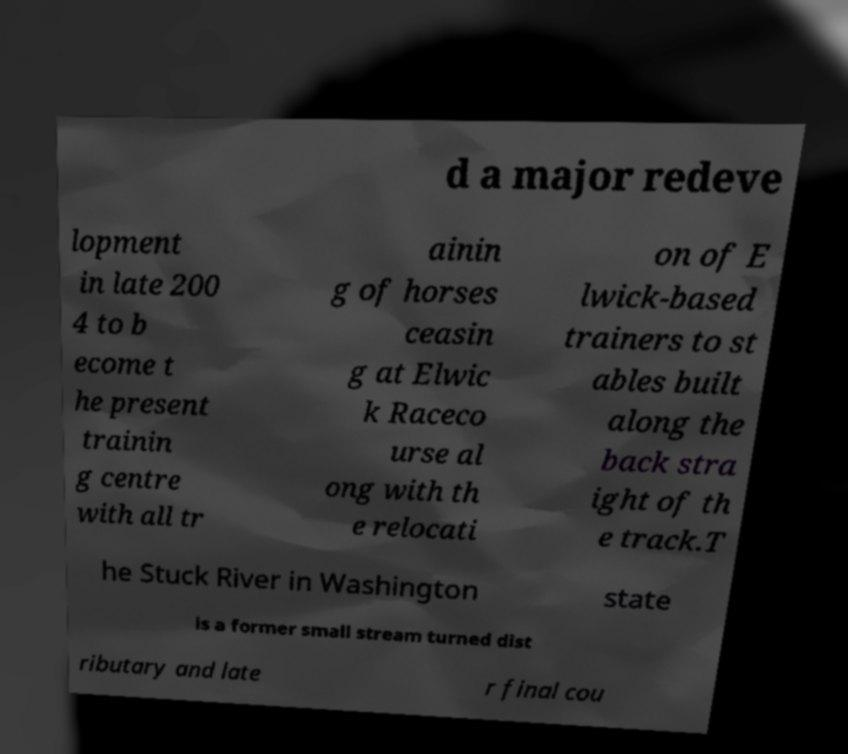Can you accurately transcribe the text from the provided image for me? d a major redeve lopment in late 200 4 to b ecome t he present trainin g centre with all tr ainin g of horses ceasin g at Elwic k Raceco urse al ong with th e relocati on of E lwick-based trainers to st ables built along the back stra ight of th e track.T he Stuck River in Washington state is a former small stream turned dist ributary and late r final cou 